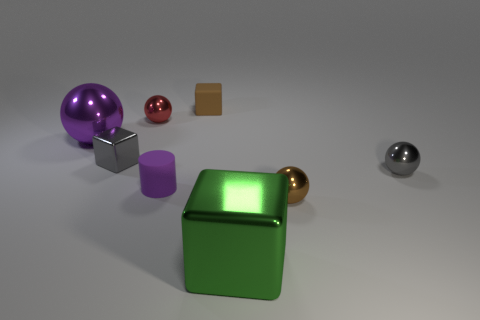Add 1 big brown metal cylinders. How many objects exist? 9 Subtract all brown spheres. How many spheres are left? 3 Subtract all red metallic spheres. How many spheres are left? 3 Subtract 1 purple cylinders. How many objects are left? 7 Subtract all blocks. How many objects are left? 5 Subtract 3 balls. How many balls are left? 1 Subtract all blue blocks. Subtract all purple cylinders. How many blocks are left? 3 Subtract all green cylinders. How many red spheres are left? 1 Subtract all tiny gray shiny cubes. Subtract all tiny purple objects. How many objects are left? 6 Add 5 large spheres. How many large spheres are left? 6 